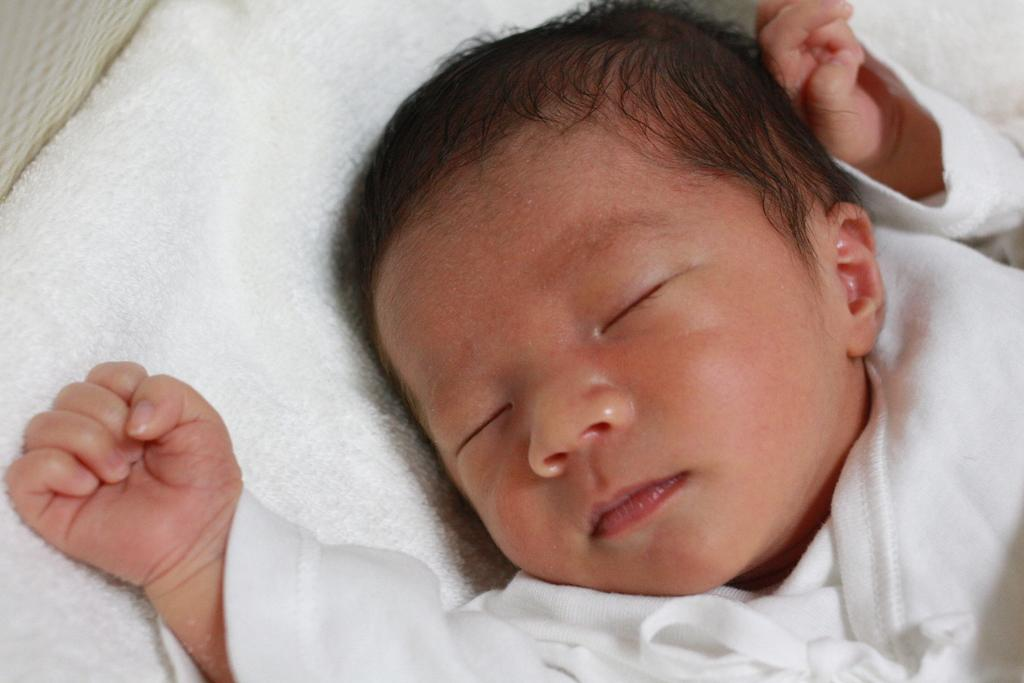What is the main subject of the image? The main subject of the image is a baby. What is the baby doing in the image? The baby is sleeping in the image. How is the baby dressed in the image? The baby is wrapped in a white towel and wearing a white dress. What does the baby's dad look like in the image? There is no dad present in the image; it only features the baby. Is the baby taking a bath in the image? No, the baby is not taking a bath in the image; the baby is wrapped in a white towel and wearing a white dress. 